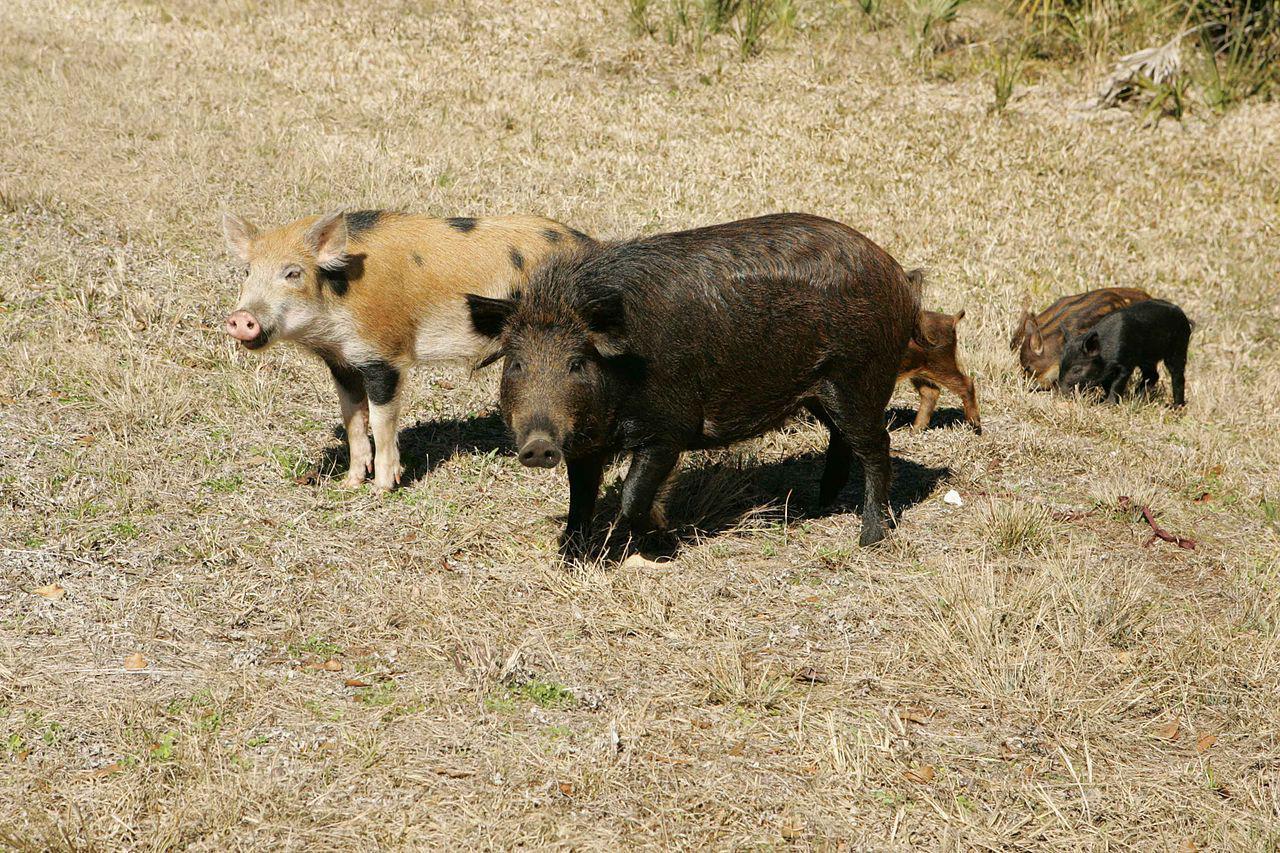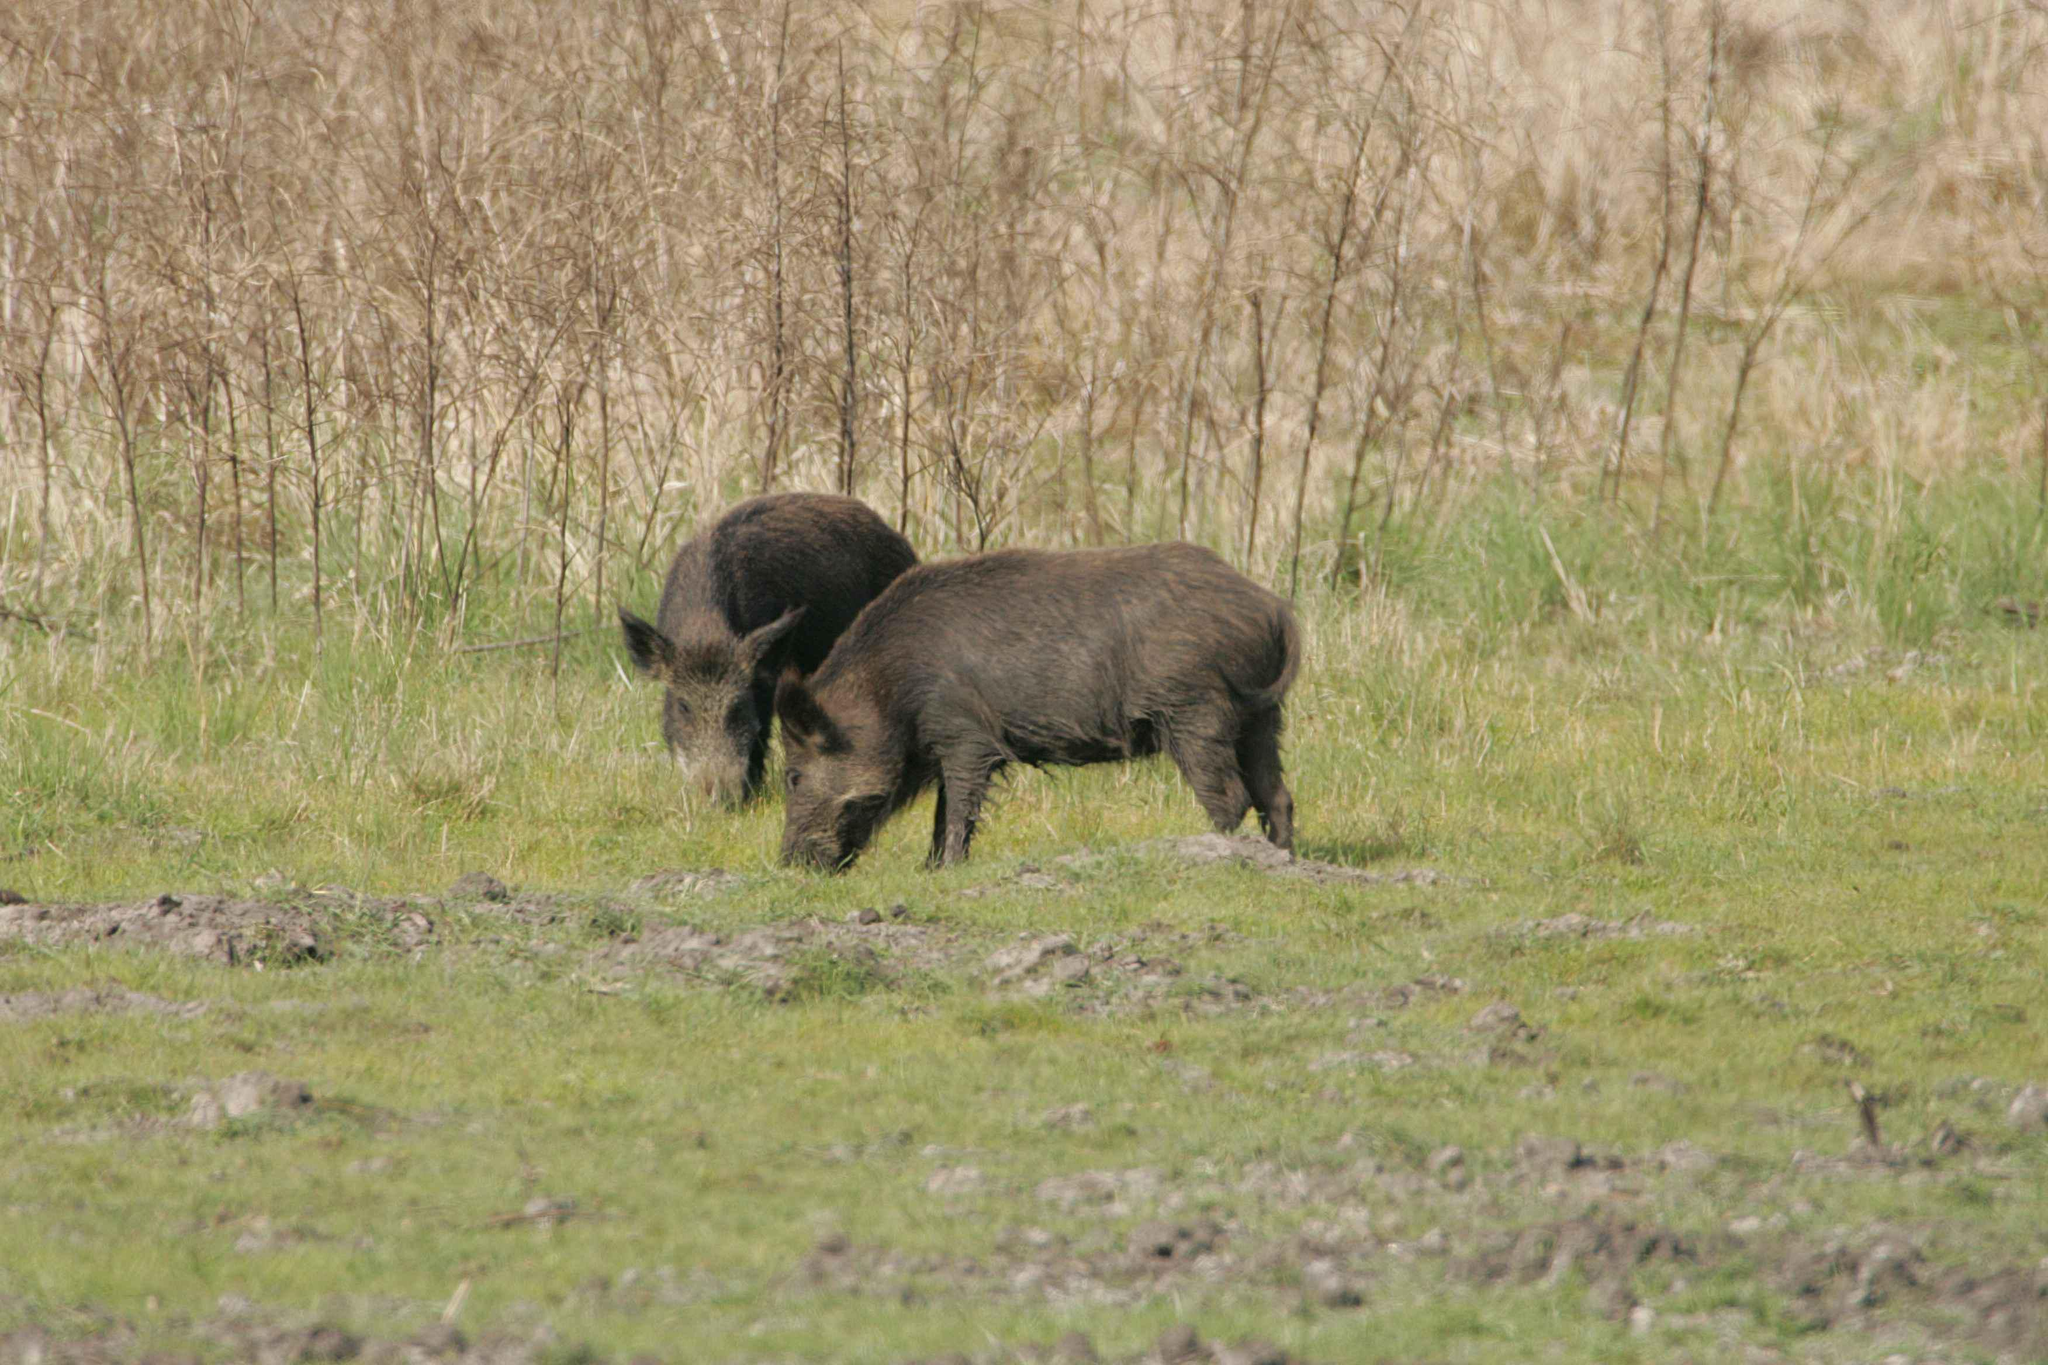The first image is the image on the left, the second image is the image on the right. Assess this claim about the two images: "At least one hog walks through the snow.". Correct or not? Answer yes or no. No. The first image is the image on the left, the second image is the image on the right. Analyze the images presented: Is the assertion "There are no more that two pigs standing in lush green grass." valid? Answer yes or no. Yes. 